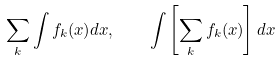Convert formula to latex. <formula><loc_0><loc_0><loc_500><loc_500>\sum _ { k } \int f _ { k } ( x ) d x , \quad \int \left [ \sum _ { k } f _ { k } ( x ) \right ] d x</formula> 